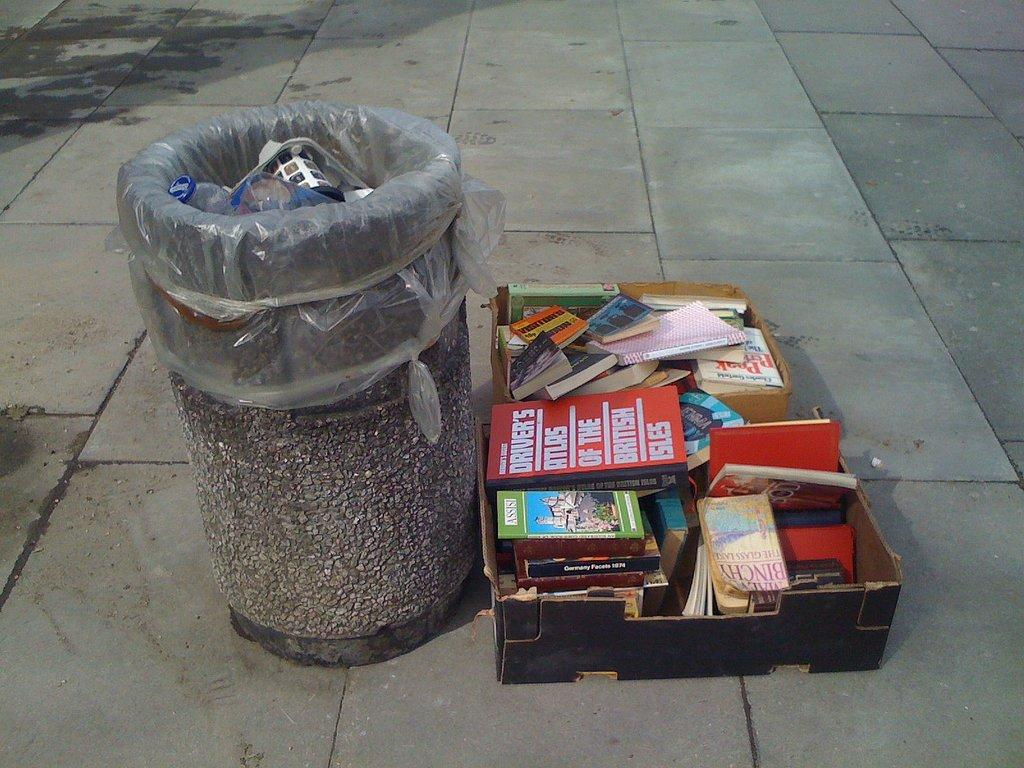What items can be seen in the image related to reading or writing? There are papers and books in the image. Where are the papers and books located? The papers and books are in a cardboard box. What is the purpose of the dustbin in the image? The dustbin is likely for disposing of unwanted papers or books. What is the color of the floor in the image? The floor is gray in color. How many volleyballs are visible in the image? There are no volleyballs present in the image. What is the rate of the books being read in the image? There is no indication of anyone reading the books in the image, so it is impossible to determine the rate at which they are being read. 